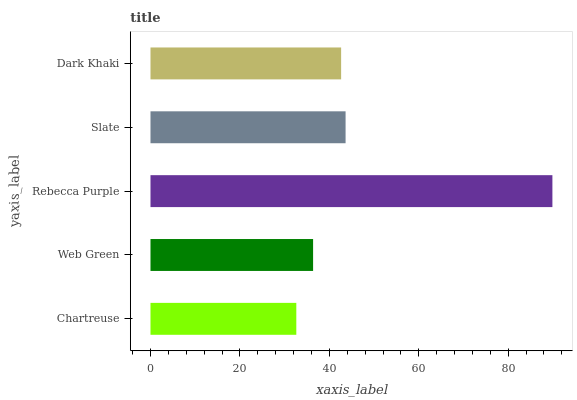Is Chartreuse the minimum?
Answer yes or no. Yes. Is Rebecca Purple the maximum?
Answer yes or no. Yes. Is Web Green the minimum?
Answer yes or no. No. Is Web Green the maximum?
Answer yes or no. No. Is Web Green greater than Chartreuse?
Answer yes or no. Yes. Is Chartreuse less than Web Green?
Answer yes or no. Yes. Is Chartreuse greater than Web Green?
Answer yes or no. No. Is Web Green less than Chartreuse?
Answer yes or no. No. Is Dark Khaki the high median?
Answer yes or no. Yes. Is Dark Khaki the low median?
Answer yes or no. Yes. Is Slate the high median?
Answer yes or no. No. Is Web Green the low median?
Answer yes or no. No. 